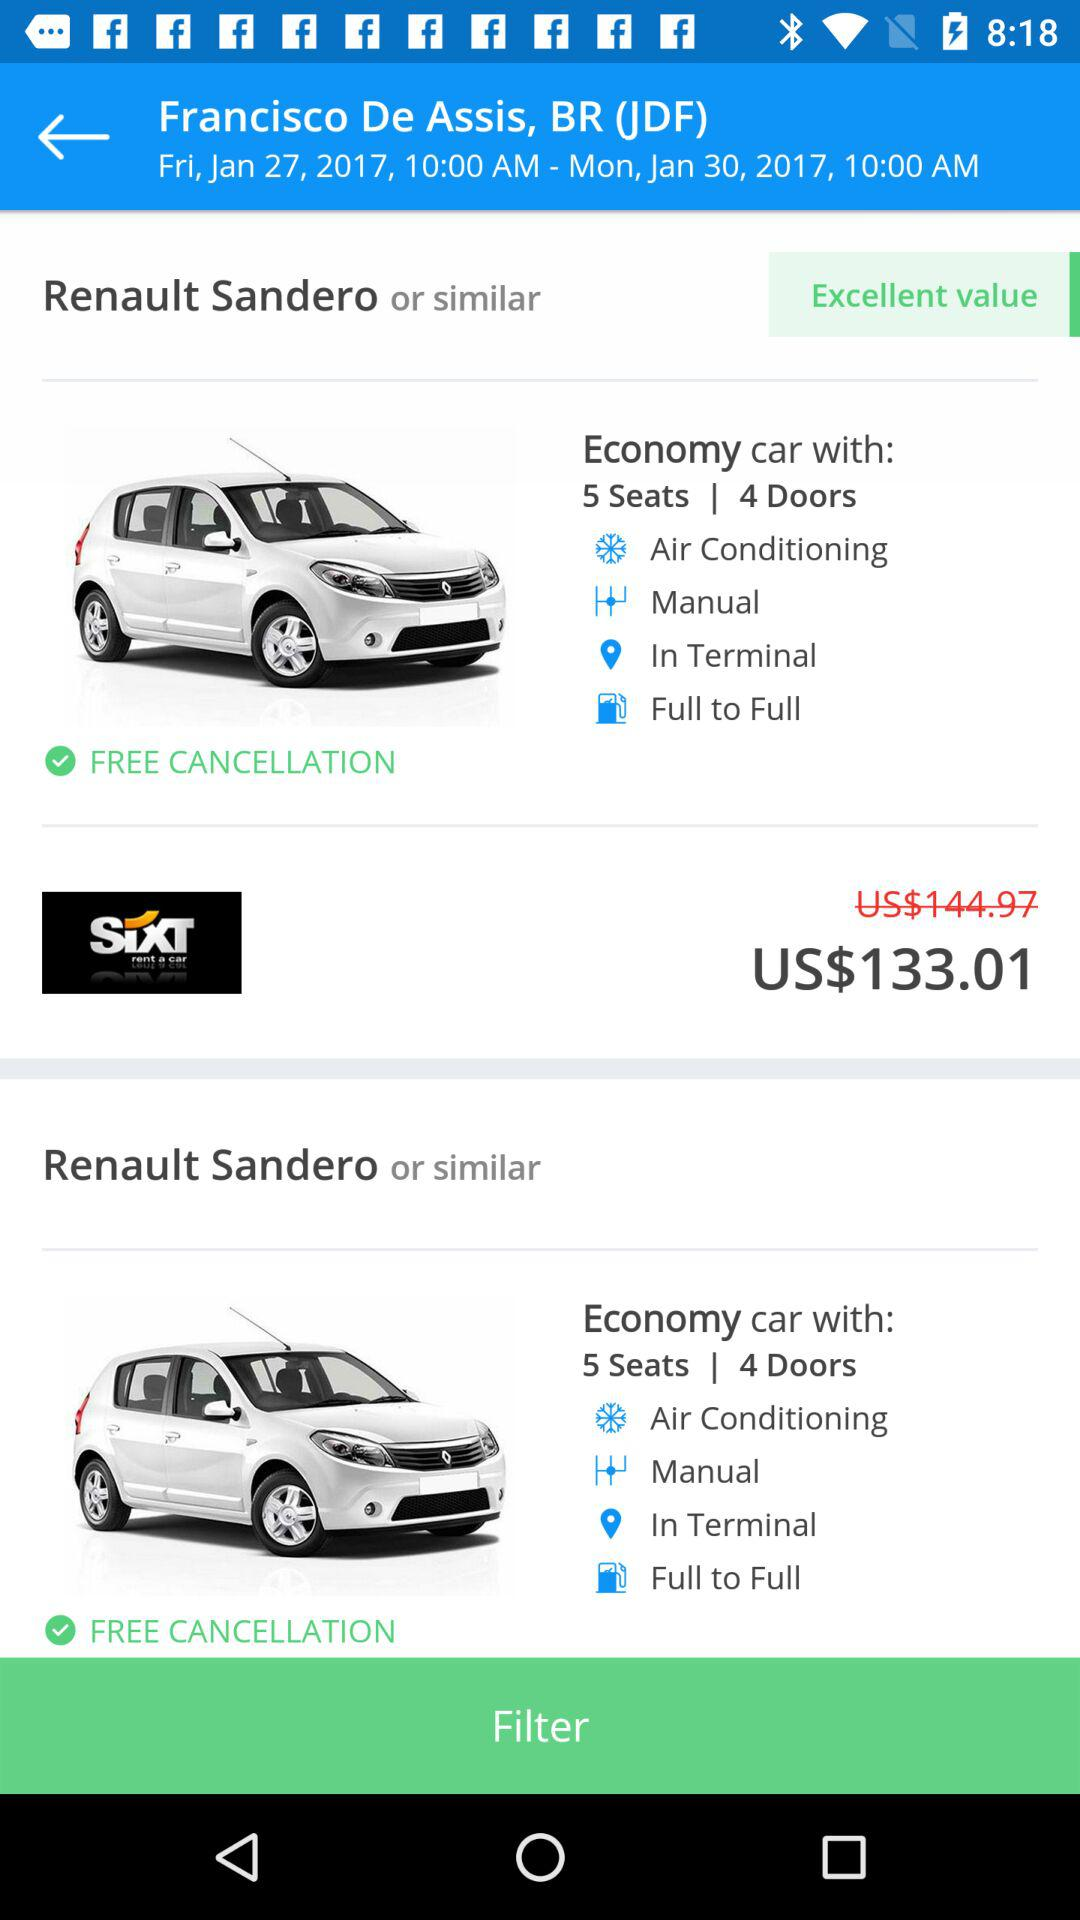What is the discounted price of the car? The discounted price of the car is US$133.01. 